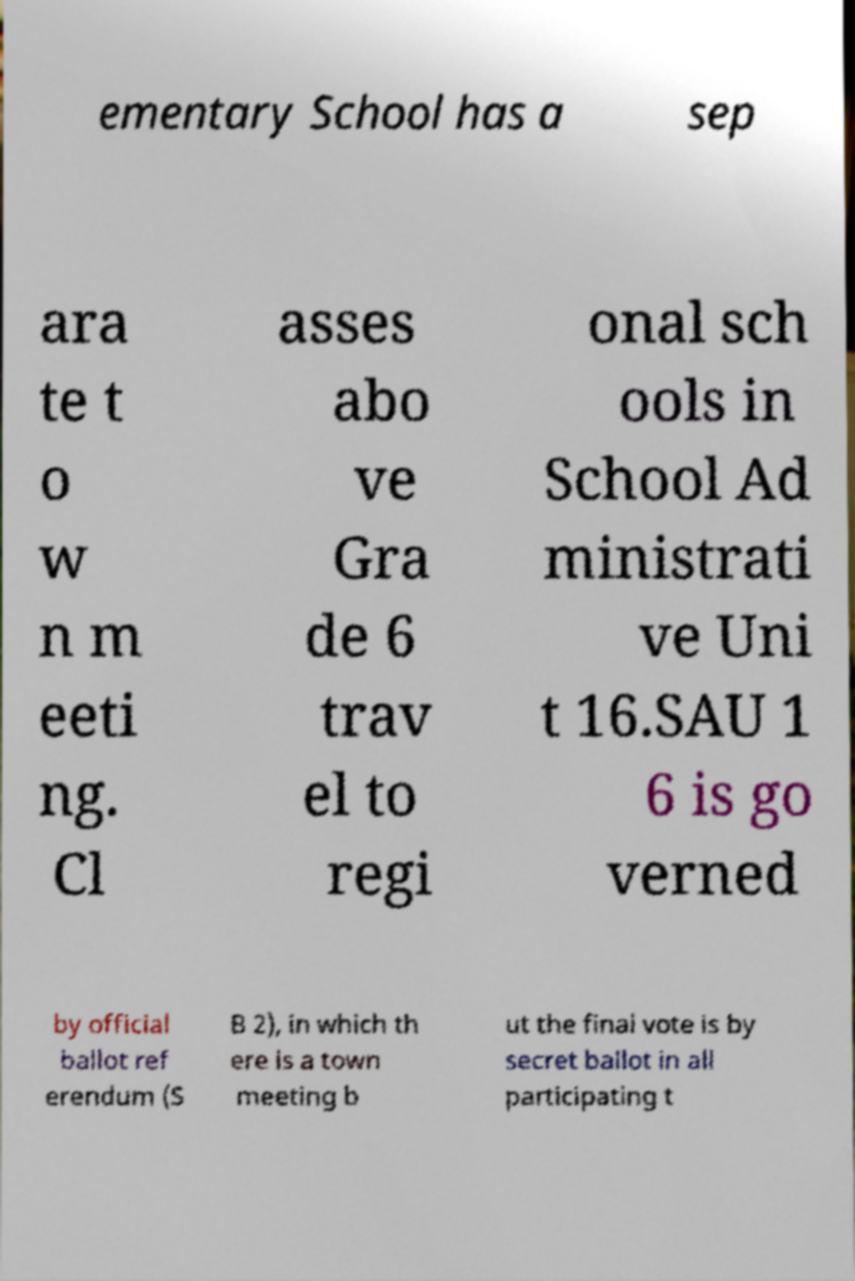What messages or text are displayed in this image? I need them in a readable, typed format. ementary School has a sep ara te t o w n m eeti ng. Cl asses abo ve Gra de 6 trav el to regi onal sch ools in School Ad ministrati ve Uni t 16.SAU 1 6 is go verned by official ballot ref erendum (S B 2), in which th ere is a town meeting b ut the final vote is by secret ballot in all participating t 